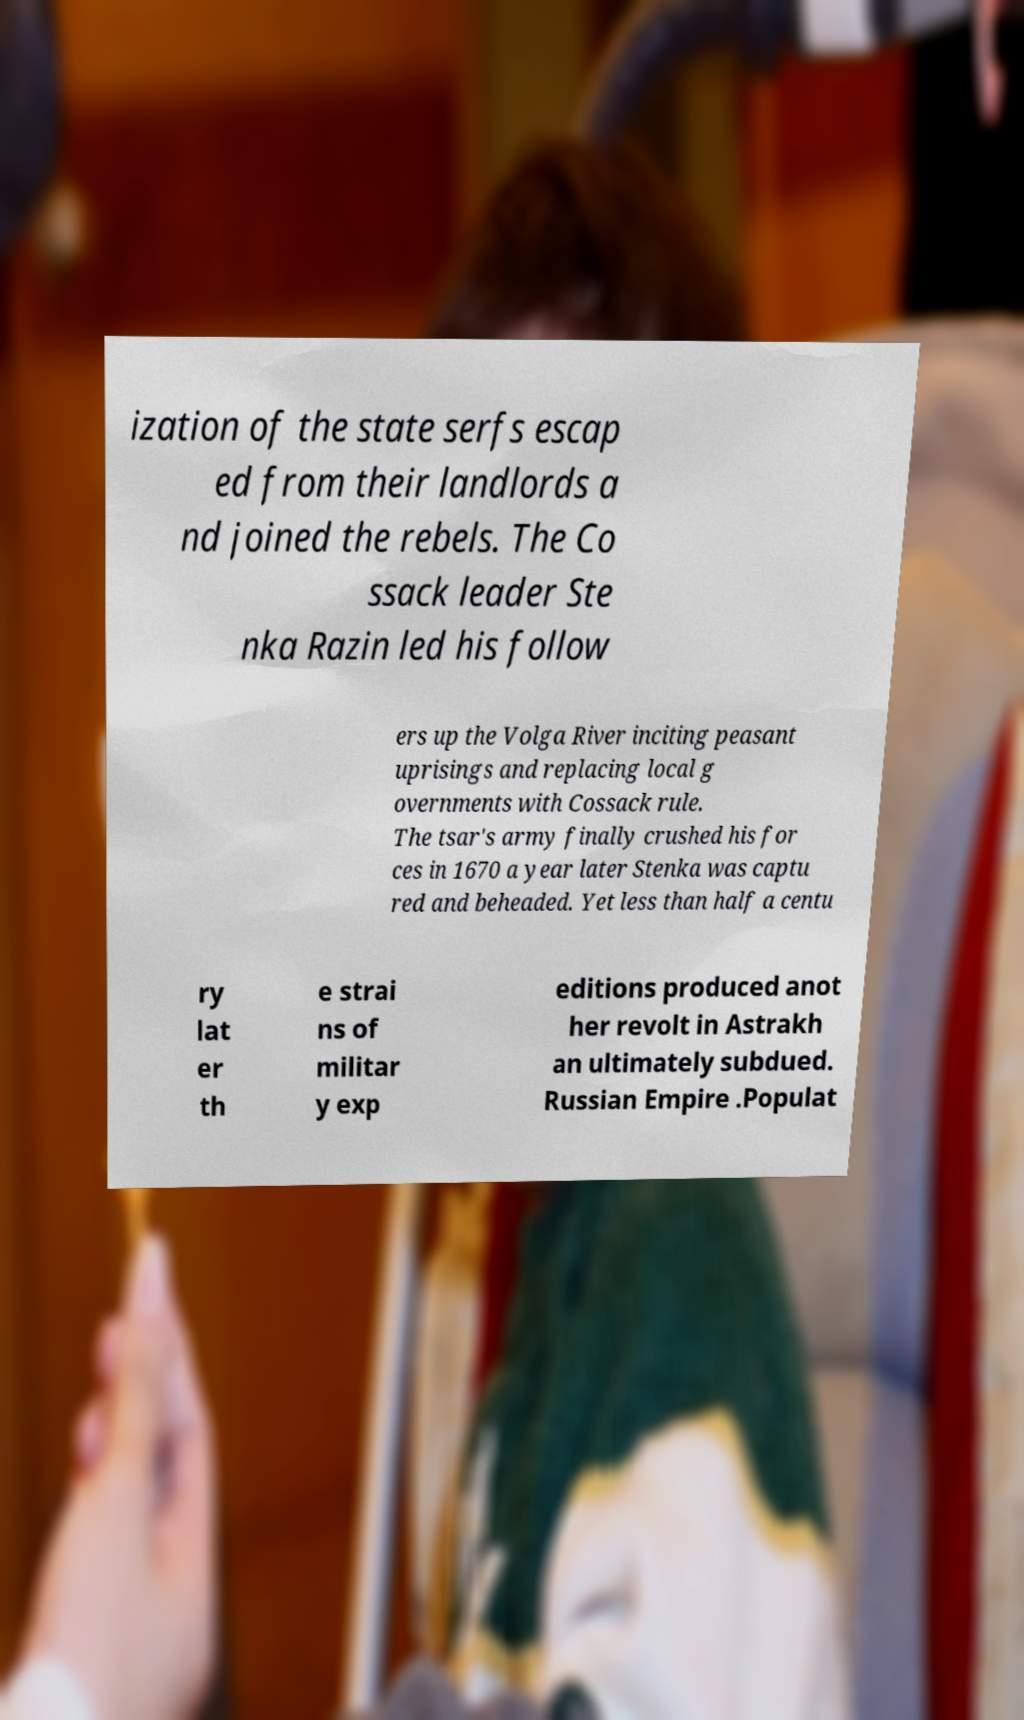There's text embedded in this image that I need extracted. Can you transcribe it verbatim? ization of the state serfs escap ed from their landlords a nd joined the rebels. The Co ssack leader Ste nka Razin led his follow ers up the Volga River inciting peasant uprisings and replacing local g overnments with Cossack rule. The tsar's army finally crushed his for ces in 1670 a year later Stenka was captu red and beheaded. Yet less than half a centu ry lat er th e strai ns of militar y exp editions produced anot her revolt in Astrakh an ultimately subdued. Russian Empire .Populat 